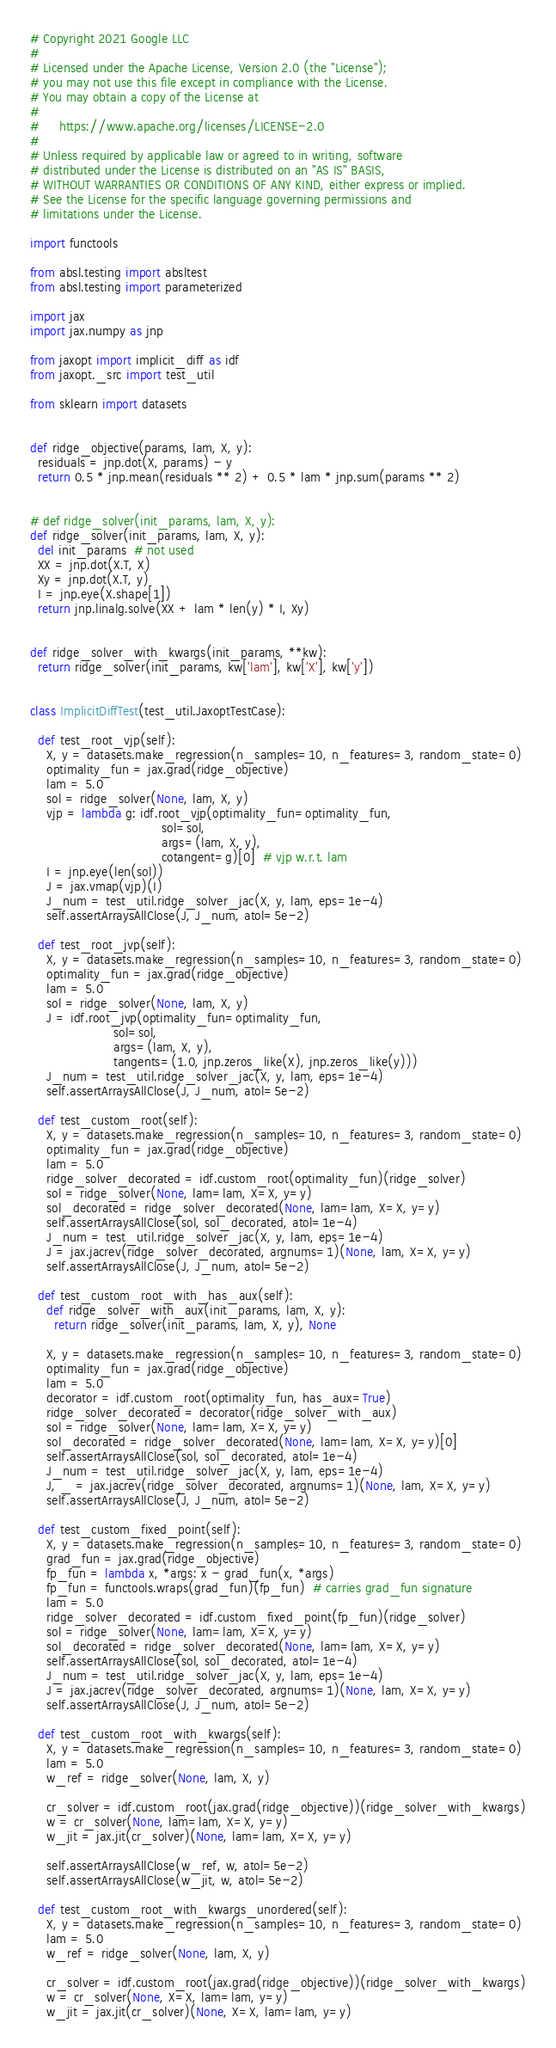Convert code to text. <code><loc_0><loc_0><loc_500><loc_500><_Python_># Copyright 2021 Google LLC
#
# Licensed under the Apache License, Version 2.0 (the "License");
# you may not use this file except in compliance with the License.
# You may obtain a copy of the License at
#
#     https://www.apache.org/licenses/LICENSE-2.0
#
# Unless required by applicable law or agreed to in writing, software
# distributed under the License is distributed on an "AS IS" BASIS,
# WITHOUT WARRANTIES OR CONDITIONS OF ANY KIND, either express or implied.
# See the License for the specific language governing permissions and
# limitations under the License.

import functools

from absl.testing import absltest
from absl.testing import parameterized

import jax
import jax.numpy as jnp

from jaxopt import implicit_diff as idf
from jaxopt._src import test_util

from sklearn import datasets


def ridge_objective(params, lam, X, y):
  residuals = jnp.dot(X, params) - y
  return 0.5 * jnp.mean(residuals ** 2) + 0.5 * lam * jnp.sum(params ** 2)


# def ridge_solver(init_params, lam, X, y):
def ridge_solver(init_params, lam, X, y):
  del init_params  # not used
  XX = jnp.dot(X.T, X)
  Xy = jnp.dot(X.T, y)
  I = jnp.eye(X.shape[1])
  return jnp.linalg.solve(XX + lam * len(y) * I, Xy)


def ridge_solver_with_kwargs(init_params, **kw):
  return ridge_solver(init_params, kw['lam'], kw['X'], kw['y'])


class ImplicitDiffTest(test_util.JaxoptTestCase):

  def test_root_vjp(self):
    X, y = datasets.make_regression(n_samples=10, n_features=3, random_state=0)
    optimality_fun = jax.grad(ridge_objective)
    lam = 5.0
    sol = ridge_solver(None, lam, X, y)
    vjp = lambda g: idf.root_vjp(optimality_fun=optimality_fun,
                                 sol=sol,
                                 args=(lam, X, y),
                                 cotangent=g)[0]  # vjp w.r.t. lam
    I = jnp.eye(len(sol))
    J = jax.vmap(vjp)(I)
    J_num = test_util.ridge_solver_jac(X, y, lam, eps=1e-4)
    self.assertArraysAllClose(J, J_num, atol=5e-2)

  def test_root_jvp(self):
    X, y = datasets.make_regression(n_samples=10, n_features=3, random_state=0)
    optimality_fun = jax.grad(ridge_objective)
    lam = 5.0
    sol = ridge_solver(None, lam, X, y)
    J = idf.root_jvp(optimality_fun=optimality_fun,
                     sol=sol,
                     args=(lam, X, y),
                     tangents=(1.0, jnp.zeros_like(X), jnp.zeros_like(y)))
    J_num = test_util.ridge_solver_jac(X, y, lam, eps=1e-4)
    self.assertArraysAllClose(J, J_num, atol=5e-2)

  def test_custom_root(self):
    X, y = datasets.make_regression(n_samples=10, n_features=3, random_state=0)
    optimality_fun = jax.grad(ridge_objective)
    lam = 5.0
    ridge_solver_decorated = idf.custom_root(optimality_fun)(ridge_solver)
    sol = ridge_solver(None, lam=lam, X=X, y=y)
    sol_decorated = ridge_solver_decorated(None, lam=lam, X=X, y=y)
    self.assertArraysAllClose(sol, sol_decorated, atol=1e-4)
    J_num = test_util.ridge_solver_jac(X, y, lam, eps=1e-4)
    J = jax.jacrev(ridge_solver_decorated, argnums=1)(None, lam, X=X, y=y)
    self.assertArraysAllClose(J, J_num, atol=5e-2)

  def test_custom_root_with_has_aux(self):
    def ridge_solver_with_aux(init_params, lam, X, y):
      return ridge_solver(init_params, lam, X, y), None

    X, y = datasets.make_regression(n_samples=10, n_features=3, random_state=0)
    optimality_fun = jax.grad(ridge_objective)
    lam = 5.0
    decorator = idf.custom_root(optimality_fun, has_aux=True)
    ridge_solver_decorated = decorator(ridge_solver_with_aux)
    sol = ridge_solver(None, lam=lam, X=X, y=y)
    sol_decorated = ridge_solver_decorated(None, lam=lam, X=X, y=y)[0]
    self.assertArraysAllClose(sol, sol_decorated, atol=1e-4)
    J_num = test_util.ridge_solver_jac(X, y, lam, eps=1e-4)
    J, _ = jax.jacrev(ridge_solver_decorated, argnums=1)(None, lam, X=X, y=y)
    self.assertArraysAllClose(J, J_num, atol=5e-2)

  def test_custom_fixed_point(self):
    X, y = datasets.make_regression(n_samples=10, n_features=3, random_state=0)
    grad_fun = jax.grad(ridge_objective)
    fp_fun = lambda x, *args: x - grad_fun(x, *args)
    fp_fun = functools.wraps(grad_fun)(fp_fun)  # carries grad_fun signature
    lam = 5.0
    ridge_solver_decorated = idf.custom_fixed_point(fp_fun)(ridge_solver)
    sol = ridge_solver(None, lam=lam, X=X, y=y)
    sol_decorated = ridge_solver_decorated(None, lam=lam, X=X, y=y)
    self.assertArraysAllClose(sol, sol_decorated, atol=1e-4)
    J_num = test_util.ridge_solver_jac(X, y, lam, eps=1e-4)
    J = jax.jacrev(ridge_solver_decorated, argnums=1)(None, lam, X=X, y=y)
    self.assertArraysAllClose(J, J_num, atol=5e-2)

  def test_custom_root_with_kwargs(self):
    X, y = datasets.make_regression(n_samples=10, n_features=3, random_state=0)
    lam = 5.0
    w_ref = ridge_solver(None, lam, X, y)

    cr_solver = idf.custom_root(jax.grad(ridge_objective))(ridge_solver_with_kwargs)
    w = cr_solver(None, lam=lam, X=X, y=y)
    w_jit = jax.jit(cr_solver)(None, lam=lam, X=X, y=y)

    self.assertArraysAllClose(w_ref, w, atol=5e-2)
    self.assertArraysAllClose(w_jit, w, atol=5e-2)

  def test_custom_root_with_kwargs_unordered(self):
    X, y = datasets.make_regression(n_samples=10, n_features=3, random_state=0)
    lam = 5.0
    w_ref = ridge_solver(None, lam, X, y)

    cr_solver = idf.custom_root(jax.grad(ridge_objective))(ridge_solver_with_kwargs)
    w = cr_solver(None, X=X, lam=lam, y=y)
    w_jit = jax.jit(cr_solver)(None, X=X, lam=lam, y=y)
</code> 